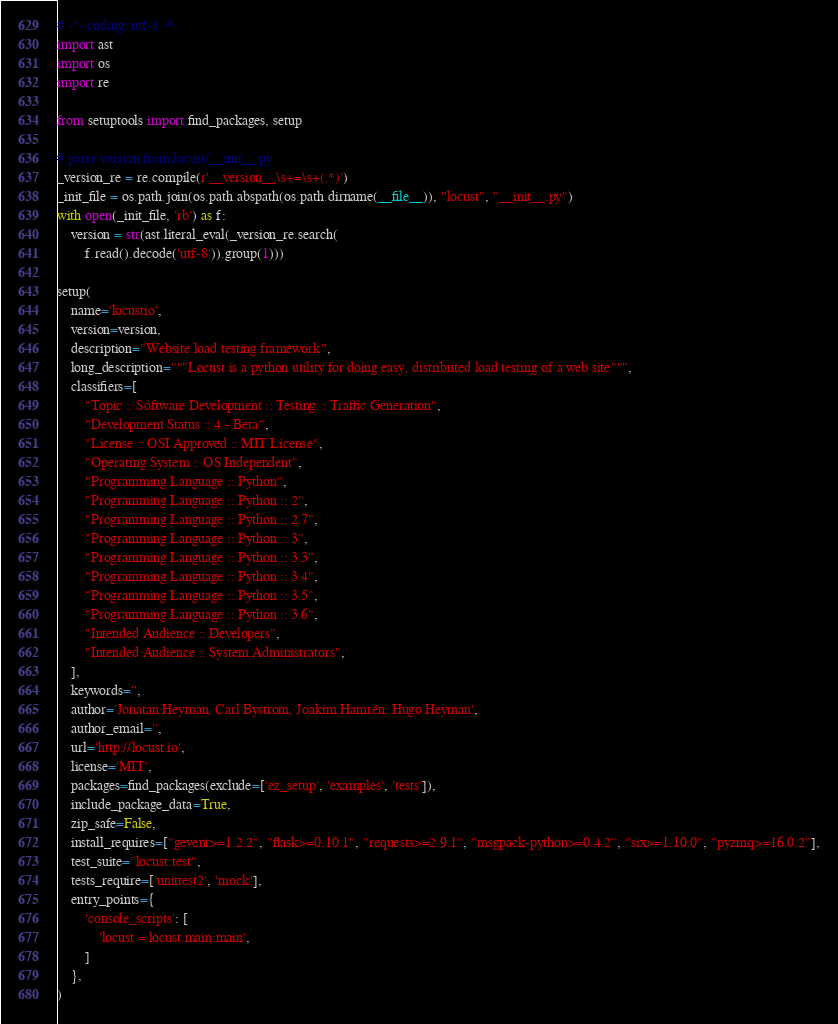<code> <loc_0><loc_0><loc_500><loc_500><_Python_># -*- coding: utf-8 -*-
import ast
import os
import re

from setuptools import find_packages, setup

# parse version from locust/__init__.py
_version_re = re.compile(r'__version__\s+=\s+(.*)')
_init_file = os.path.join(os.path.abspath(os.path.dirname(__file__)), "locust", "__init__.py")
with open(_init_file, 'rb') as f:
    version = str(ast.literal_eval(_version_re.search(
        f.read().decode('utf-8')).group(1)))

setup(
    name='locustio',
    version=version,
    description="Website load testing framework",
    long_description="""Locust is a python utility for doing easy, distributed load testing of a web site""",
    classifiers=[
        "Topic :: Software Development :: Testing :: Traffic Generation",
        "Development Status :: 4 - Beta",
        "License :: OSI Approved :: MIT License",
        "Operating System :: OS Independent",
        "Programming Language :: Python",
        "Programming Language :: Python :: 2",
        "Programming Language :: Python :: 2.7",
        "Programming Language :: Python :: 3",
        "Programming Language :: Python :: 3.3",
        "Programming Language :: Python :: 3.4",
        "Programming Language :: Python :: 3.5",
        "Programming Language :: Python :: 3.6",
        "Intended Audience :: Developers",
        "Intended Audience :: System Administrators",
    ],
    keywords='',
    author='Jonatan Heyman, Carl Bystrom, Joakim Hamrén, Hugo Heyman',
    author_email='',
    url='http://locust.io',
    license='MIT',
    packages=find_packages(exclude=['ez_setup', 'examples', 'tests']),
    include_package_data=True,
    zip_safe=False,
    install_requires=["gevent>=1.2.2", "flask>=0.10.1", "requests>=2.9.1", "msgpack-python>=0.4.2", "six>=1.10.0", "pyzmq>=16.0.2"],
    test_suite="locust.test",
    tests_require=['unittest2', 'mock'],
    entry_points={
        'console_scripts': [
            'locust = locust.main:main',
        ]
    },
)
</code> 